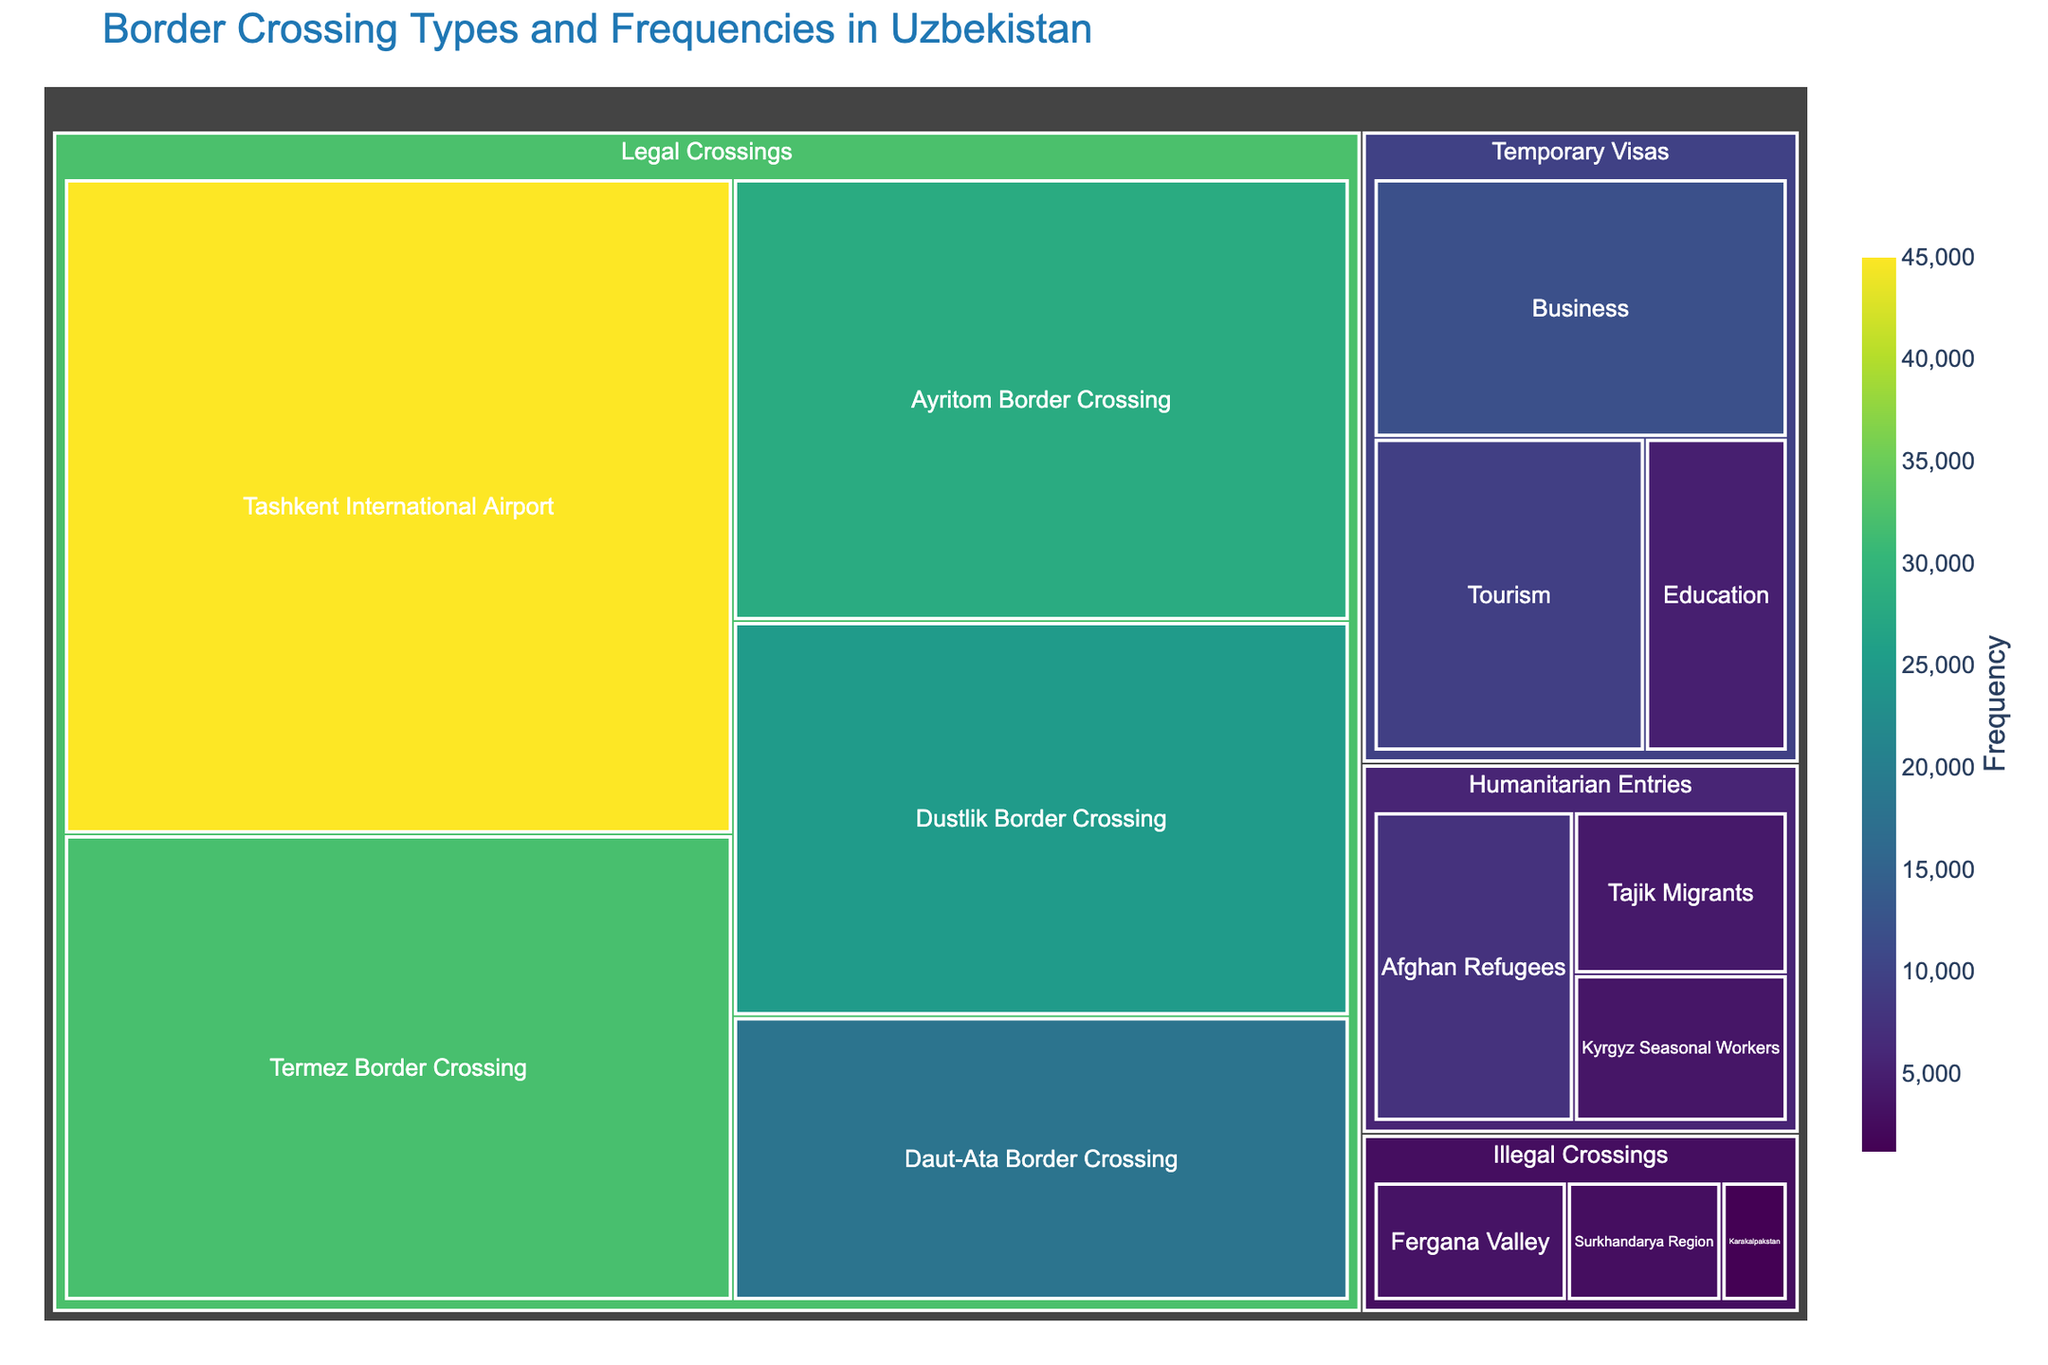What's the most frequent type of border crossing at Uzbekistan's entry points? Look at the largest section in the treemap. The section for Tashkent International Airport under Legal Crossings is the largest, indicating it has the highest frequency.
Answer: Legal Crossings at Tashkent International Airport Which category has the fewest crossings overall? Compare the total values for each of the main categories. The Illegal Crossings category has the smallest segments in terms of area. Adding up its values gives 3500 + 2800 + 1200 = 7500. This is less than the totals for Legal Crossings, Humanitarian Entries, and Temporary Visas.
Answer: Illegal Crossings What is the combined total of humanitarian entries? Sum the values for all subcategories under the Humanitarian Entries category: 7500 (Afghan Refugees) + 4200 (Tajik Migrants) + 3800 (Kyrgyz Seasonal Workers) = 15500.
Answer: 15,500 Which subcategory under Temporary Visas has the smallest frequency? Compare the areas of the segments under Temporary Visas. The area representing Education is the smallest, indicating it has the lowest frequency among Business, Tourism, and Education.
Answer: Education Is there a greater frequency of legal crossings or temporary visas? Add the values for all subcategories under Legal Crossings and Temporary Visas. Legal Crossings: 45000 + 32000 + 28000 + 25000 + 18000 = 148000. Temporary Visas: 12000 + 9500 + 5000 = 26500. Compare the totals: 148000 > 26500.
Answer: Legal Crossings What’s the difference in frequency between the largest and smallest subcategories within legal crossings? Identify the largest and smallest subcategories under Legal Crossings. The largest is Tashkent International Airport with 45000, and the smallest is Daut-Ata Border Crossing with 18000. Difference: 45000 - 18000 = 27000.
Answer: 27,000 How do illegal crossings in the Fergana Valley compare to humanitarian entries for Tajik migrants? Find and compare the values of both subcategories. Fergana Valley has 3500 illegal crossings, while Tajik Migrants have 4200 humanitarian entries. 3500 < 4200.
Answer: Less What percentage of total border crossings are due to tourist visas? Find the value for tourism under Temporary Visas and divide it by the total of all values: (9500 / (45000 + 32000 + 28000 + 25000 + 18000 + 3500 + 2800 + 1200 + 7500 + 4200 + 3800 + 12000 + 9500 + 5000)) x 100 = approximately 3.13%.
Answer: 3.13% What is the ratio of legal crossings at Tashkent International Airport to illegal crossings in the Surkhandarya Region? Tashkent International Airport has 45000 crossings, and Surkhandarya Region has 2800 illegal crossings. Ratio: 45000 : 2800 = 16.07.
Answer: 16.07 